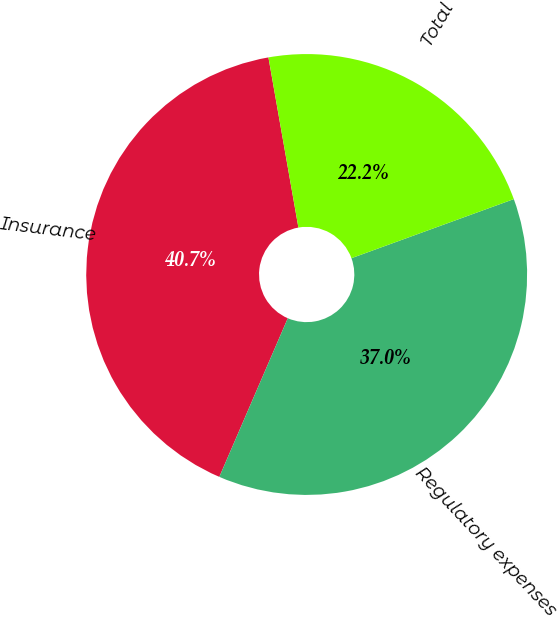<chart> <loc_0><loc_0><loc_500><loc_500><pie_chart><fcel>Insurance<fcel>Regulatory expenses<fcel>Total<nl><fcel>40.74%<fcel>37.04%<fcel>22.22%<nl></chart> 